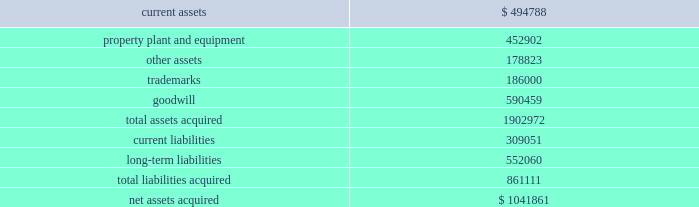Mondavi produces , markets and sells premium , super-premium and fine california wines under the woodbridge by robert mondavi , robert mondavi private selection and robert mondavi winery brand names .
Woodbridge and robert mondavi private selection are the leading premium and super-premium wine brands by volume , respectively , in the united states .
The acquisition of robert mondavi supports the company 2019s strategy of strengthening the breadth of its portfolio across price segments to capitalize on the overall growth in the pre- mium , super-premium and fine wine categories .
The company believes that the acquired robert mondavi brand names have strong brand recognition globally .
The vast majority of robert mondavi 2019s sales are generated in the united states .
The company intends to leverage the robert mondavi brands in the united states through its selling , marketing and distribution infrastructure .
The company also intends to further expand distribution for the robert mondavi brands in europe through its constellation europe infrastructure .
The company and robert mondavi have complementary busi- nesses that share a common growth orientation and operating philosophy .
The robert mondavi acquisition provides the company with a greater presence in the fine wine sector within the united states and the ability to capitalize on the broader geographic distribution in strategic international markets .
The robert mondavi acquisition supports the company 2019s strategy of growth and breadth across categories and geographies , and strengthens its competitive position in its core markets .
In par- ticular , the company believes there are growth opportunities for premium , super-premium and fine wines in the united kingdom , united states and other wine markets .
Total consid- eration paid in cash to the robert mondavi shareholders was $ 1030.7 million .
Additionally , the company expects to incur direct acquisition costs of $ 11.2 million .
The purchase price was financed with borrowings under the company 2019s 2004 credit agreement ( as defined in note 9 ) .
In accordance with the pur- chase method of accounting , the acquired net assets are recorded at fair value at the date of acquisition .
The purchase price was based primarily on the estimated future operating results of robert mondavi , including the factors described above , as well as an estimated benefit from operating cost synergies .
The results of operations of the robert mondavi business are reported in the constellation wines segment and have been included in the consolidated statement of income since the acquisition date .
The table summarizes the estimated fair values of the assets acquired and liabilities assumed in the robert mondavi acquisition at the date of acquisition .
The company is in the process of obtaining third-party valuations of certain assets and liabilities , and refining its restructuring plan which is under development and will be finalized during the company 2019s year ending february 28 , 2006 ( see note19 ) .
Accordingly , the allocation of the purchase price is subject to refinement .
Estimated fair values at december 22 , 2004 , are as follows : {in thousands} .
The trademarks are not subject to amortization .
None of the goodwill is expected to be deductible for tax purposes .
In connection with the robert mondavi acquisition and robert mondavi 2019s previously disclosed intention to sell certain of its winery properties and related assets , and other vineyard prop- erties , the company has classified certain assets as held for sale as of february 28 , 2005 .
The company expects to sell these assets during the year ended february 28 , 2006 , for net pro- ceeds of approximately $ 150 million to $ 175 million .
No gain or loss is expected to be recognized upon the sale of these assets .
Hardy acquisition 2013 on march 27 , 2003 , the company acquired control of brl hardy limited , now known as hardy wine company limited ( 201chardy 201d ) , and on april 9 , 2003 , the company completed its acquisition of all of hardy 2019s outstanding capital stock .
As a result of the acquisition of hardy , the company also acquired the remaining 50% ( 50 % ) ownership of pacific wine partners llc ( 201cpwp 201d ) , the joint venture the company established with hardy in july 2001 .
The acquisition of hardy along with the remaining interest in pwp is referred to together as the 201chardy acquisition . 201d through this acquisition , the company acquired one of australia 2019s largest wine producers with interests in winer- ies and vineyards in most of australia 2019s major wine regions as well as new zealand and the united states and hardy 2019s market- ing and sales operations in the united kingdom .
Total consideration paid in cash and class a common stock to the hardy shareholders was $ 1137.4 million .
Additionally , the company recorded direct acquisition costs of $ 17.2 million .
The acquisition date for accounting purposes is march 27 , 2003 .
The company has recorded a $ 1.6 million reduction in the purchase price to reflect imputed interest between the accounting acquisition date and the final payment of consider- ation .
This charge is included as interest expense in the consolidated statement of income for the year ended february 29 , 2004 .
The cash portion of the purchase price paid to the hardy shareholders and optionholders ( $ 1060.2 mil- lion ) was financed with $ 660.2 million of borrowings under the company 2019s then existing credit agreement and $ 400.0 million .
What percent of the hardy acquisition was paid in cash? 
Computations: (400.0 / 1060.2)
Answer: 0.37729. 